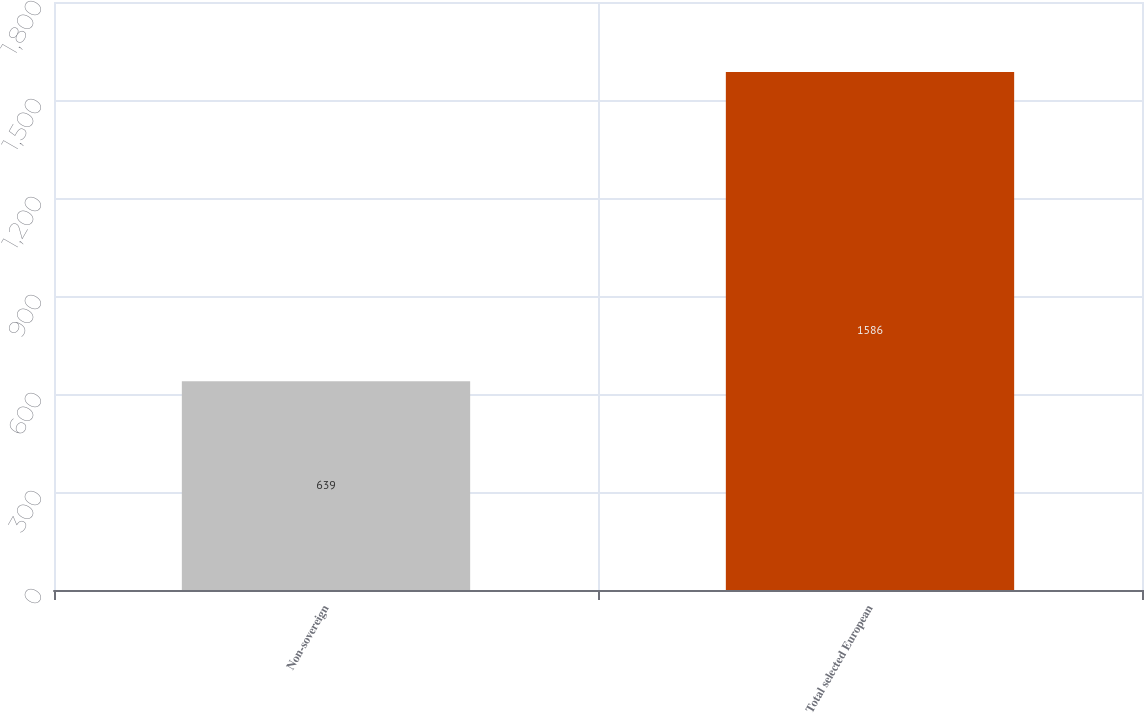<chart> <loc_0><loc_0><loc_500><loc_500><bar_chart><fcel>Non-sovereign<fcel>Total selected European<nl><fcel>639<fcel>1586<nl></chart> 